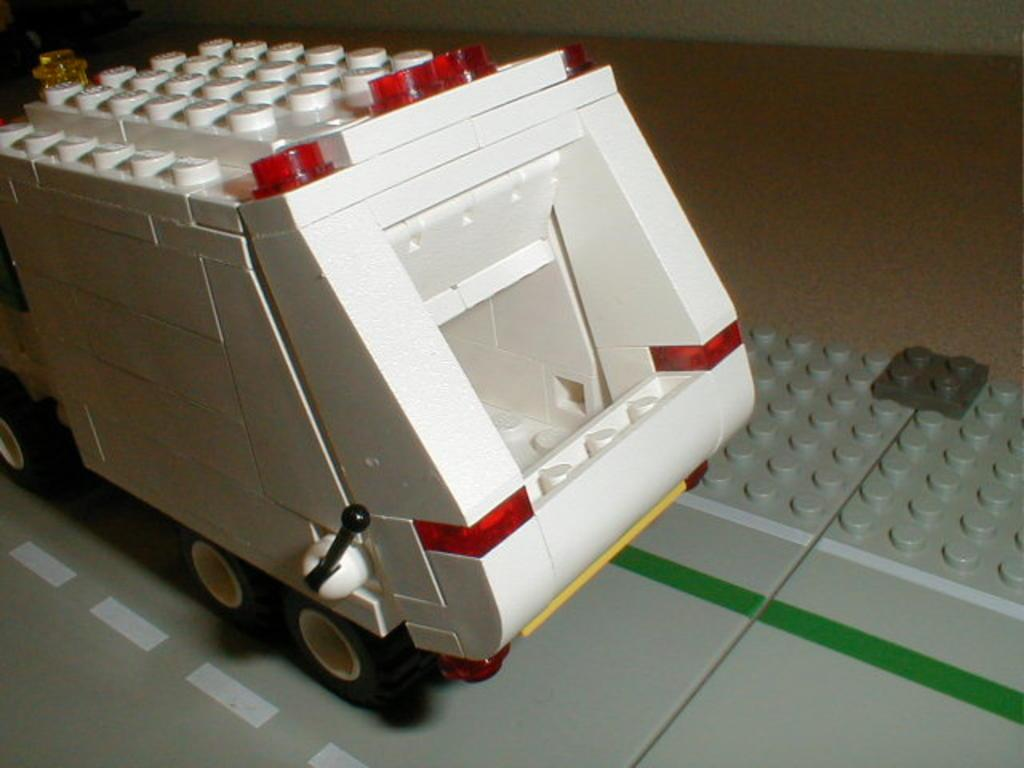What type of object is on the floor in the image? There is an object that looks like a lego toy on the floor in the image. Can you tell me who created the lizards in the image? There are no lizards present in the image, so it is not possible to determine who created them. 